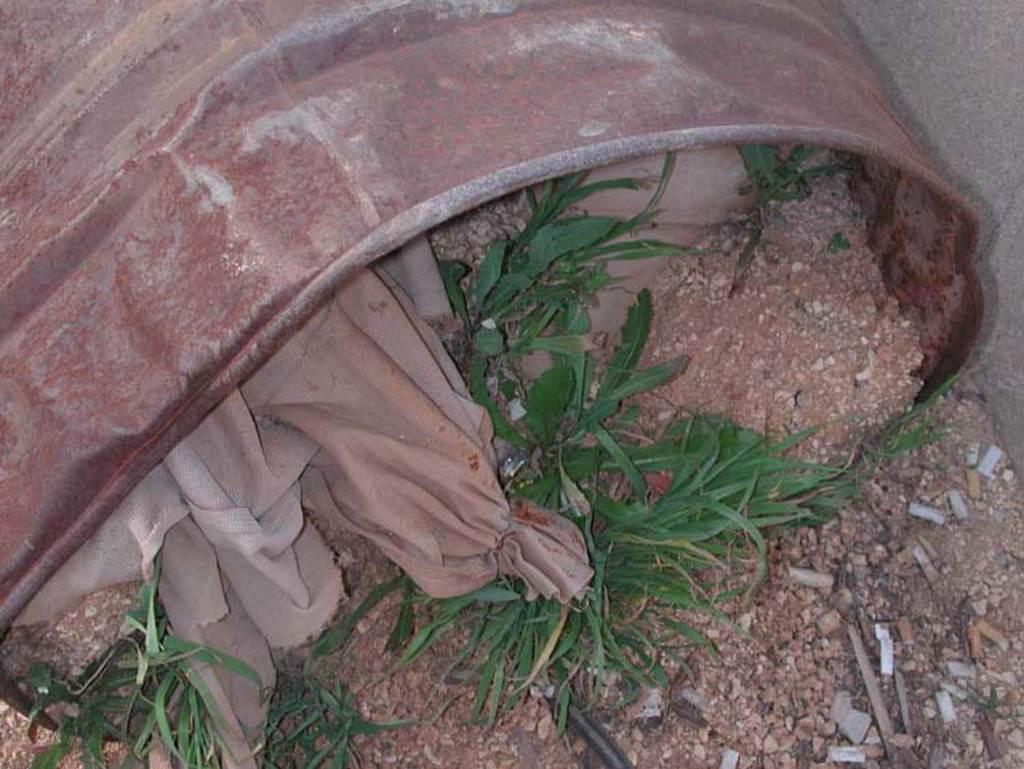What object is brown in color and present in the image? There is a brown color drum in the image. What is inside the drum? There are stones and plants in the drum. What else is present in the drum? There is a cloth in the drum. Where is the drum located? The drum is placed on the road. What team is saying good-bye to the thing in the image? There is no team or good-bye event depicted in the image; it features a drum with stones, plants, and a cloth on the road. 